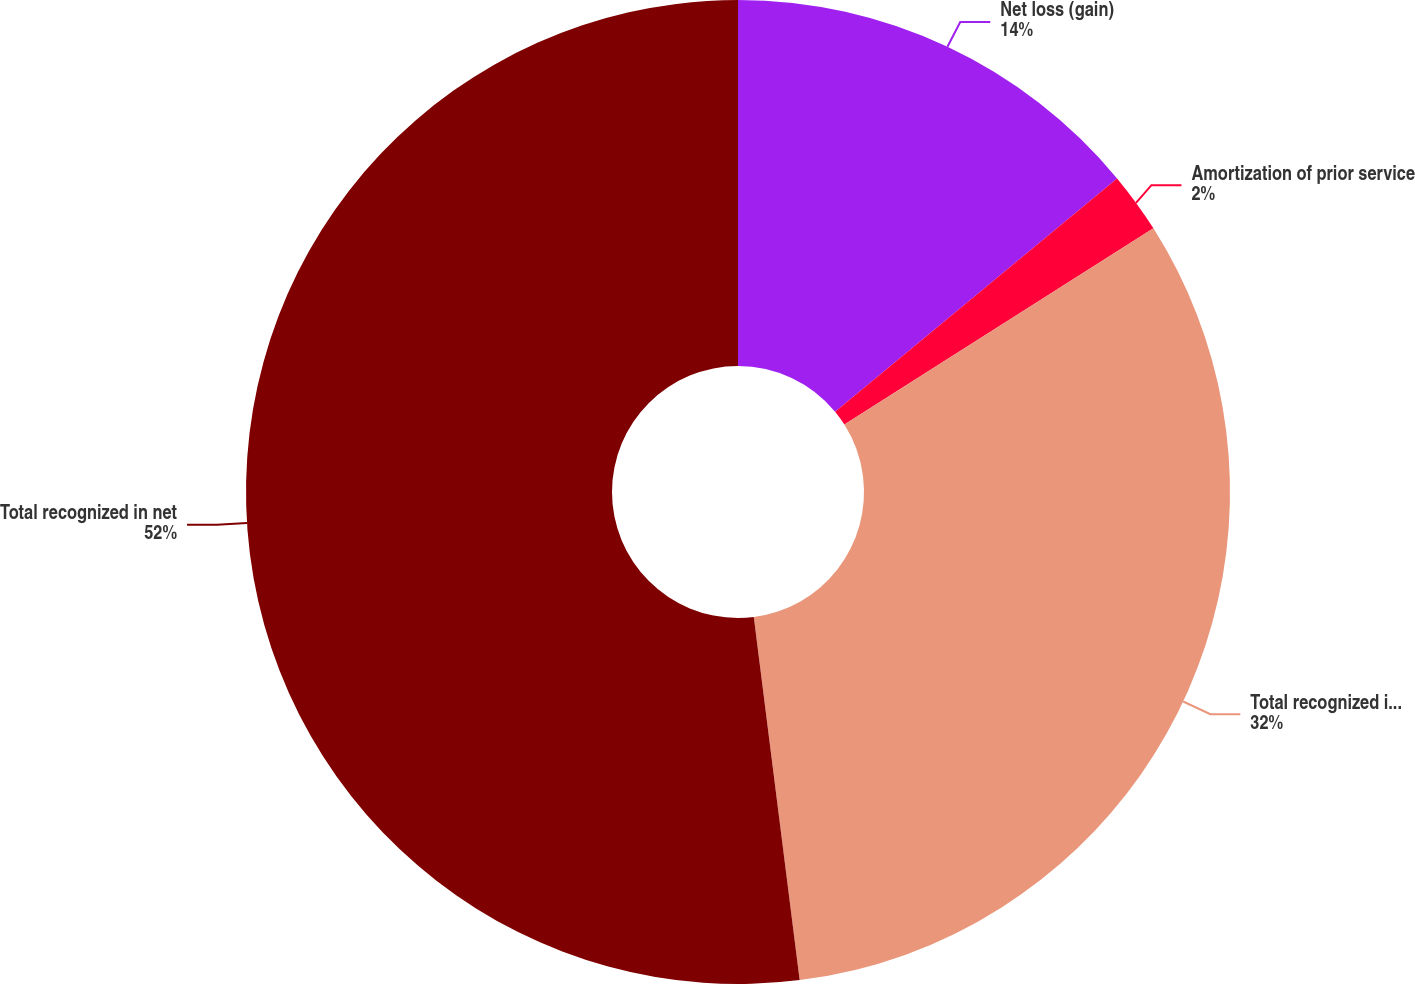<chart> <loc_0><loc_0><loc_500><loc_500><pie_chart><fcel>Net loss (gain)<fcel>Amortization of prior service<fcel>Total recognized in Other<fcel>Total recognized in net<nl><fcel>14.0%<fcel>2.0%<fcel>32.0%<fcel>52.0%<nl></chart> 